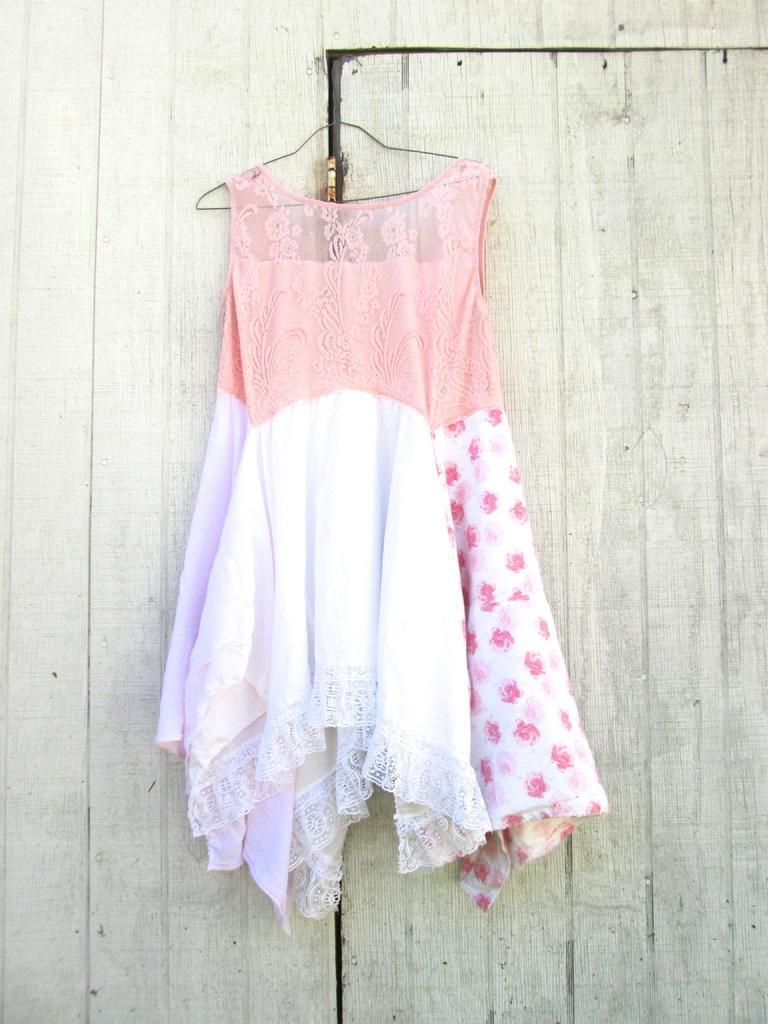Describe this image in one or two sentences. In this picture we can see a door on the right side, there is a hanger and dress in the middle. 